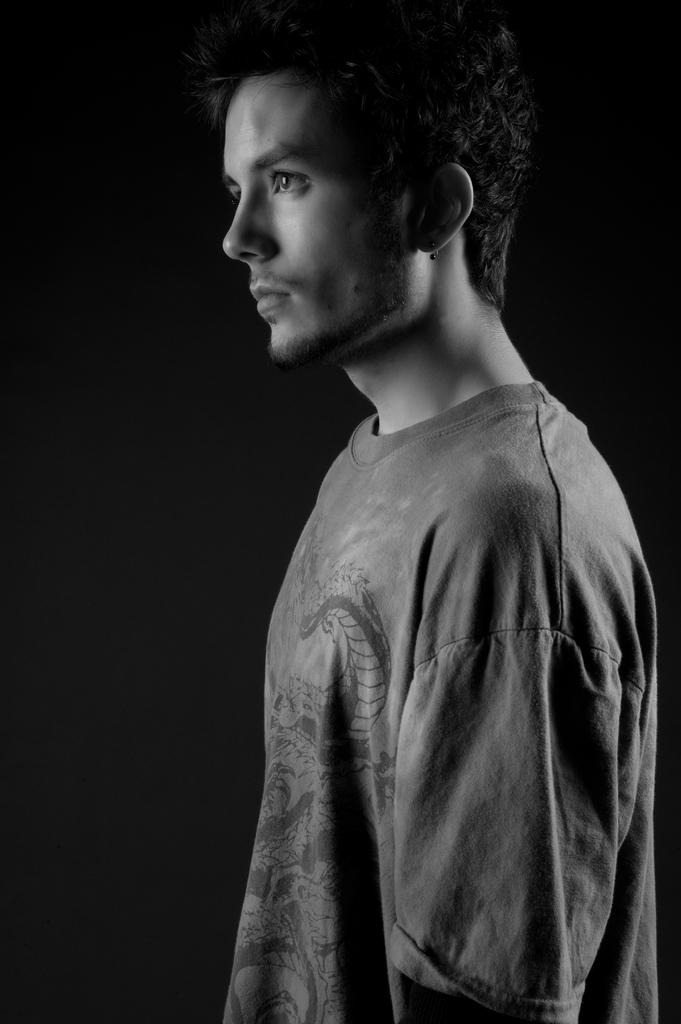Who is the main subject in the image? There is a man in the picture. What is the man doing in the image? The man is standing. What is the man wearing in the image? The man is wearing a t-shirt. What can be observed about the background of the image? The background of the image is dark. What type of riddle can be seen on the man's t-shirt in the image? There is no riddle visible on the man's t-shirt in the image. Can you tell me how many corn plants are growing in the background of the image? There are no corn plants present in the image; the background is dark. 